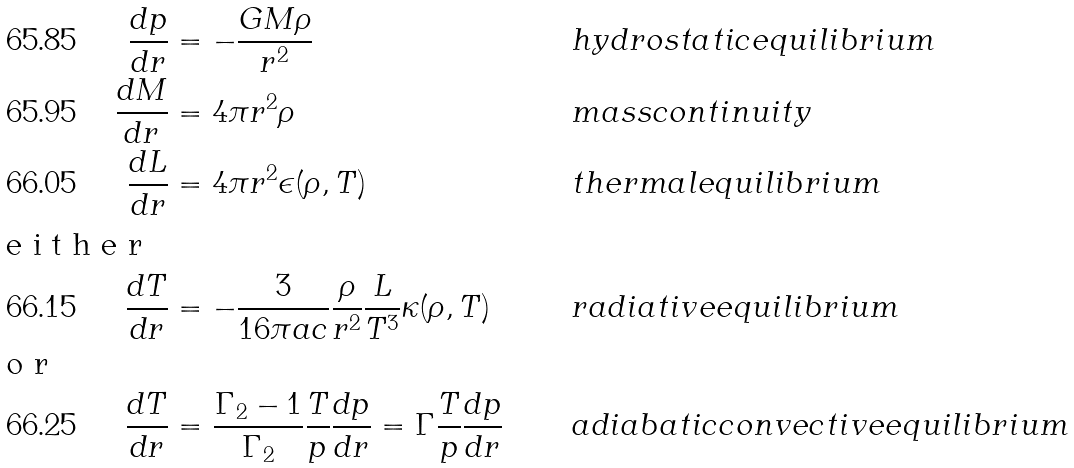Convert formula to latex. <formula><loc_0><loc_0><loc_500><loc_500>\frac { d p } { d r } & = - \frac { G M \rho } { r ^ { 2 } } & \quad & h y d r o s t a t i c e q u i l i b r i u m \\ \frac { d M } { d r } & = 4 \pi r ^ { 2 } \rho & \quad & m a s s c o n t i n u i t y \\ \frac { d L } { d r } & = 4 \pi r ^ { 2 } \epsilon ( \rho , T ) & \quad & t h e r m a l e q u i l i b r i u m \\ \intertext { e i t h e r } \frac { d T } { d r } & = - \frac { 3 } { 1 6 \pi a c } \frac { \rho } { r ^ { 2 } } \frac { L } { T ^ { 3 } } \kappa ( \rho , T ) & \quad & r a d i a t i v e e q u i l i b r i u m \\ \intertext { o r } \frac { d T } { d r } & = \frac { \Gamma _ { 2 } - 1 } { \Gamma _ { 2 } } \frac { T } { p } \frac { d p } { d r } = \Gamma \frac { T } { p } \frac { d p } { d r } & \quad & a d i a b a t i c c o n v e c t i v e e q u i l i b r i u m</formula> 